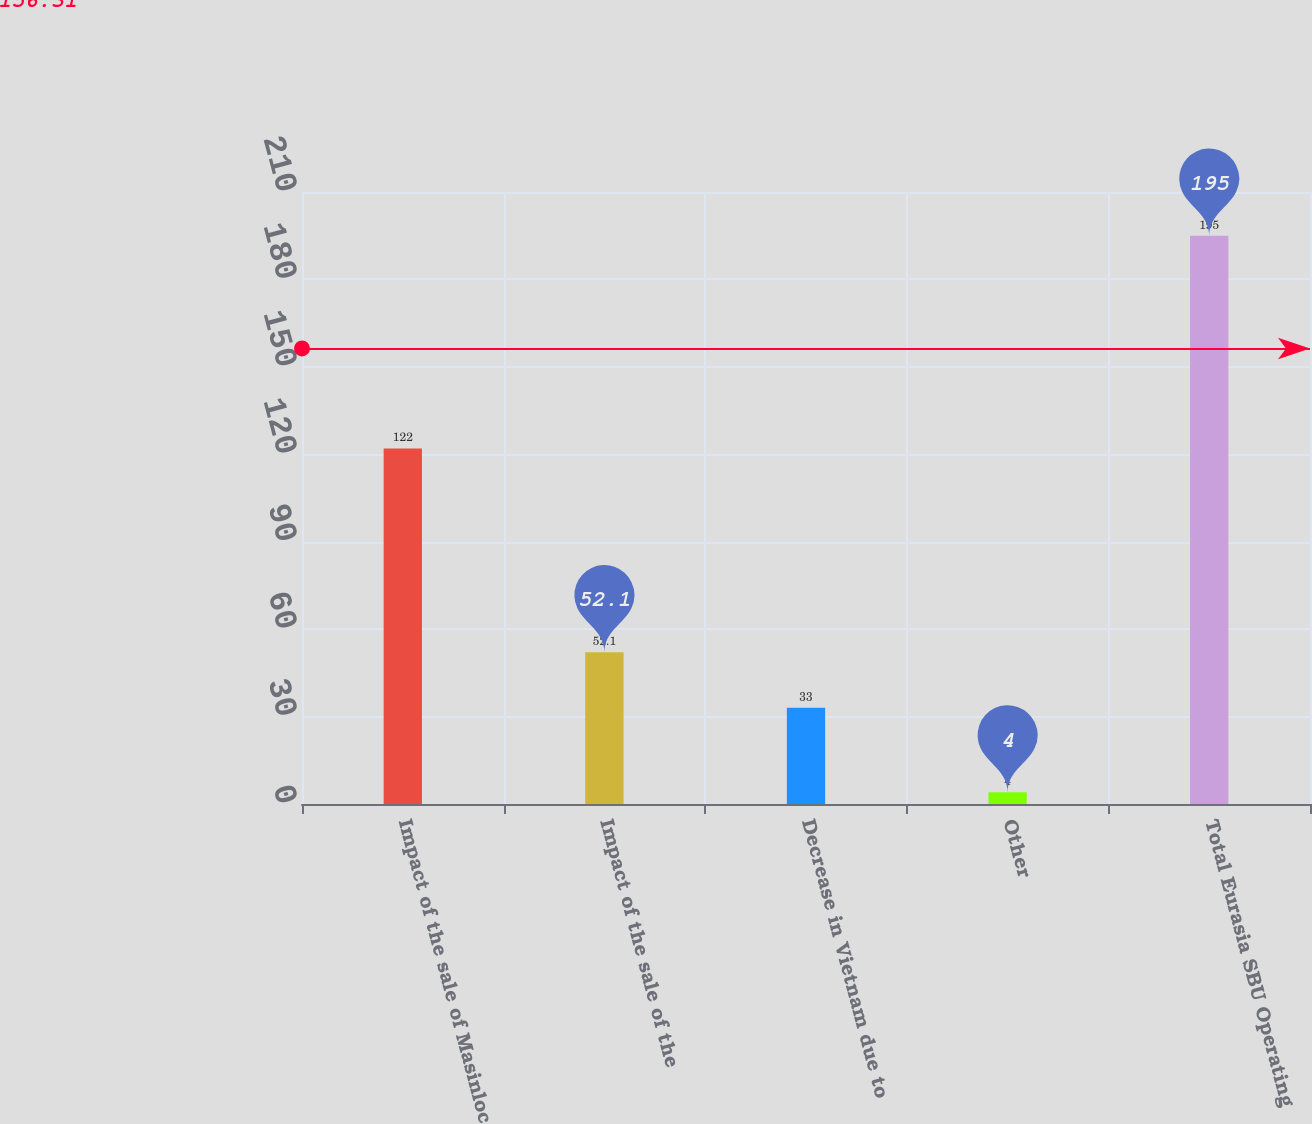Convert chart. <chart><loc_0><loc_0><loc_500><loc_500><bar_chart><fcel>Impact of the sale of Masinloc<fcel>Impact of the sale of the<fcel>Decrease in Vietnam due to<fcel>Other<fcel>Total Eurasia SBU Operating<nl><fcel>122<fcel>52.1<fcel>33<fcel>4<fcel>195<nl></chart> 